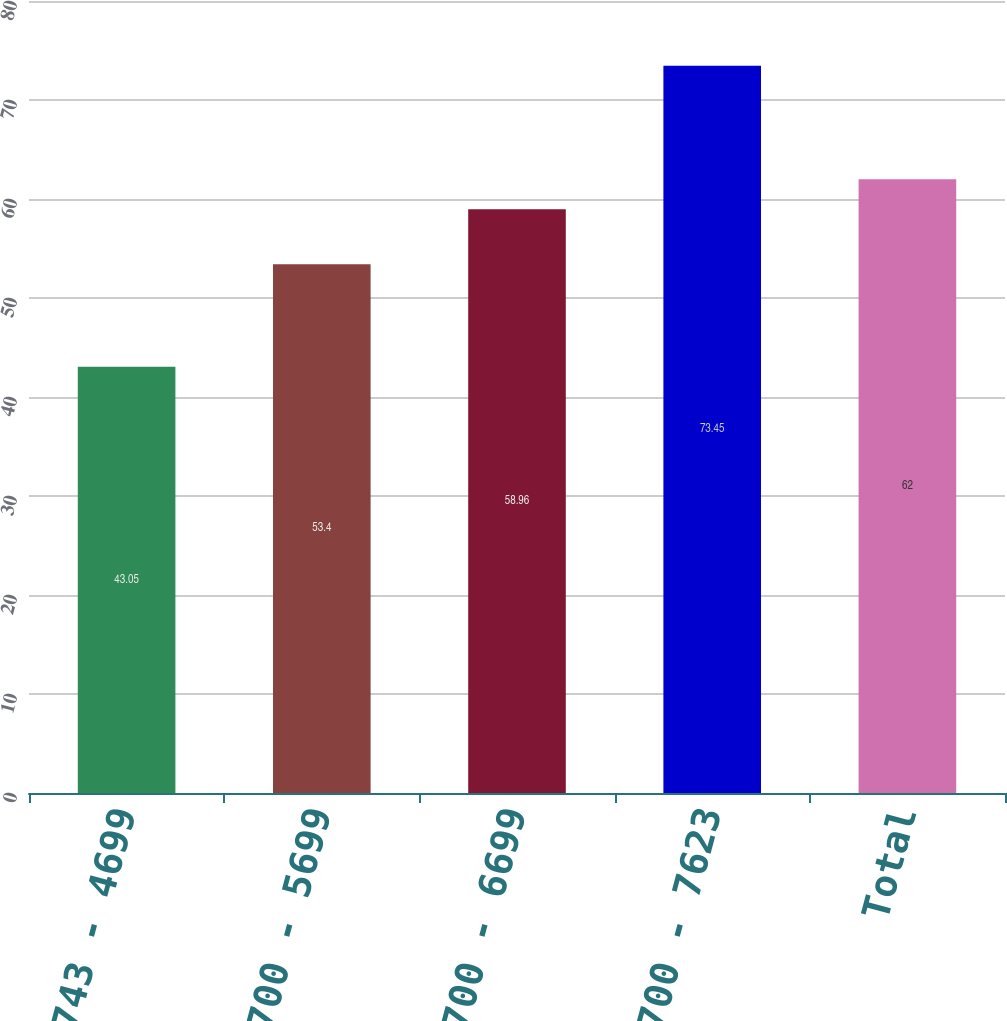Convert chart. <chart><loc_0><loc_0><loc_500><loc_500><bar_chart><fcel>3743 - 4699<fcel>4700 - 5699<fcel>5700 - 6699<fcel>6700 - 7623<fcel>Total<nl><fcel>43.05<fcel>53.4<fcel>58.96<fcel>73.45<fcel>62<nl></chart> 